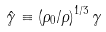<formula> <loc_0><loc_0><loc_500><loc_500>\hat { \gamma } \equiv \left ( \rho _ { 0 } / \rho \right ) ^ { 1 / 3 } \gamma</formula> 